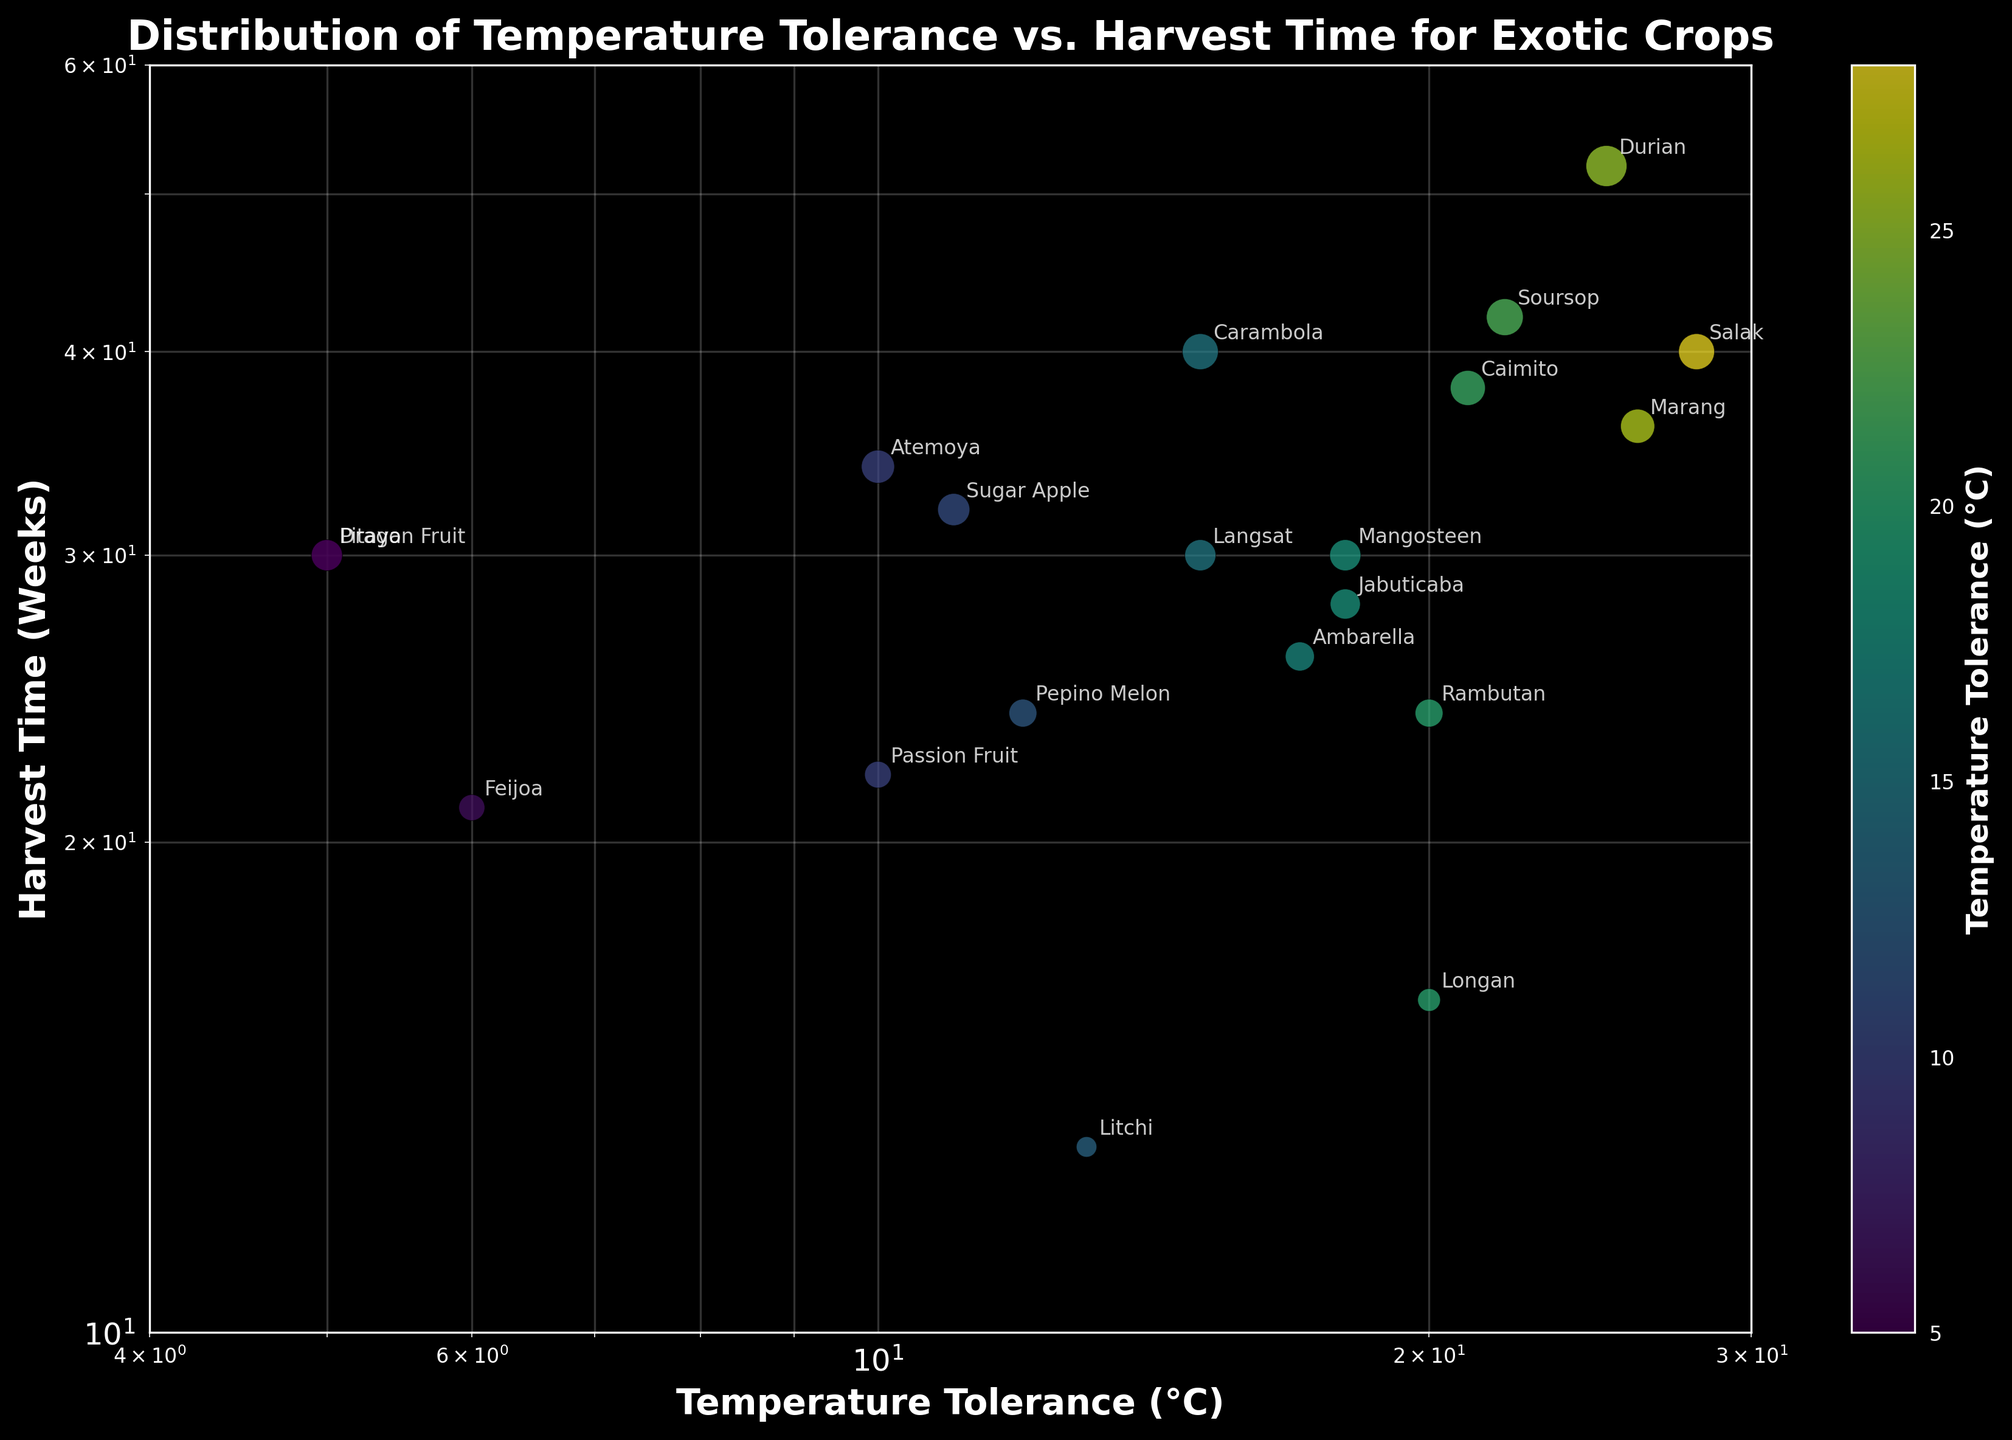What is the title of the scatter plot? The title is usually found at the top of the figure and it helps to understand the main subject of the plot.
Answer: Distribution of Temperature Tolerance vs. Harvest Time for Exotic Crops Which crop has the highest temperature tolerance? The highest temperature tolerance will be the point farthest to the right on the x-axis. Salak has the highest temperature tolerance at 28°C.
Answer: Salak How many data points represent crops with a temperature tolerance of 10°C? Look for points along the x-axis where the temperature tolerance is 10°C. There are two points: Passion Fruit and Atemoya.
Answer: 2 What is the harvest time range (difference between the maximum and minimum harvest times) for the crops? Find the crop with the maximum harvest time and the one with the minimum harvest time, then calculate the difference. Maximum is Durian at 52 weeks, and minimum is Litchi at 13 weeks. The range is 52 - 13 = 39 weeks.
Answer: 39 weeks Which crop has the shortest harvest time? The shortest harvest time is the point closest to the bottom on the y-axis. Litchi has the shortest harvest time at 13 weeks.
Answer: Litchi Which crop pair has the same temperature tolerance but different harvest times? Find points that align vertically (same x-axis value) but have different y-axis values. Dragon Fruit and Pitaya both tolerate 5°C but have different harvest times (30 weeks each).
Answer: Dragon Fruit and Pitaya Which crop is located at the intersection of log scales 20°C temperature tolerance and 24 weeks harvest time? Identify the point where 20°C on the x-axis and 24 weeks on the y-axis intersect. The crop at this intersection is Rambutan.
Answer: Rambutan How many crops have a harvest time longer than 40 weeks? Identify points above the 40 weeks mark on the y-axis. Crops with a harvest time longer than 40 weeks are Carambola, Durian, Soursop, and Caimito. There are 4 crops.
Answer: 4 Which crops are located between 15°C and 20°C temperature tolerance on the log scale? Identify points where the x-axis value lies between 15°C and 20°C. The crops are Mangosteen, Rambutan, Longan, Langsat, Jabuticaba, and Ambarella.
Answer: Mangosteen, Rambutan, Longan, Langsat, Jabuticaba, Ambarella What is the average harvest time for crops with a temperature tolerance less than 10°C? First, identify the crops below 10°C (Dragon Fruit, Feijoa, and Pitaya) and sum their harvest times: 30 (Dragon Fruit) + 21 (Feijoa) + 30 (Pitaya) = 81. Then divide by the number of crops, which is 3. 81/3 = 27 weeks.
Answer: 27 weeks 